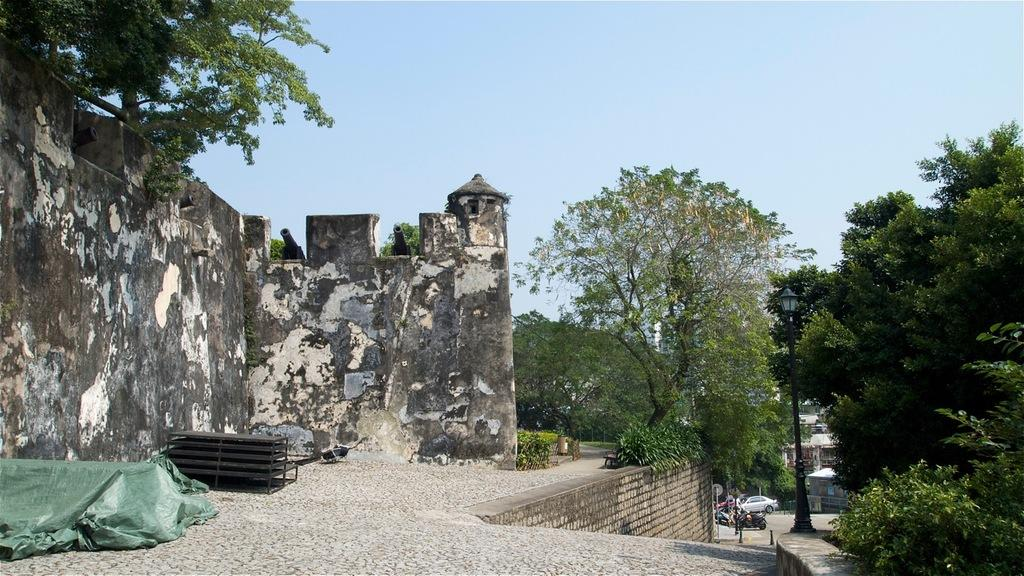What type of weapon is visible in the image? There are cannons in the image. Where are the cannons located? The cannons are at a fort. What other structures can be seen in the image? There are buildings in the image. What type of transportation is present on the road in the image? Vehicles are present on the road in the image. What type of vertical structures are visible in the image? There are poles in the image. What type of natural vegetation is visible in the image? Trees are visible in the image. What part of the natural environment is visible in the background of the image? The sky is visible in the background of the image. How many doors can be seen on the cannons in the image? There are no doors present on the cannons in the image. What type of birds can be seen flying in the image? There are no birds visible in the image. 